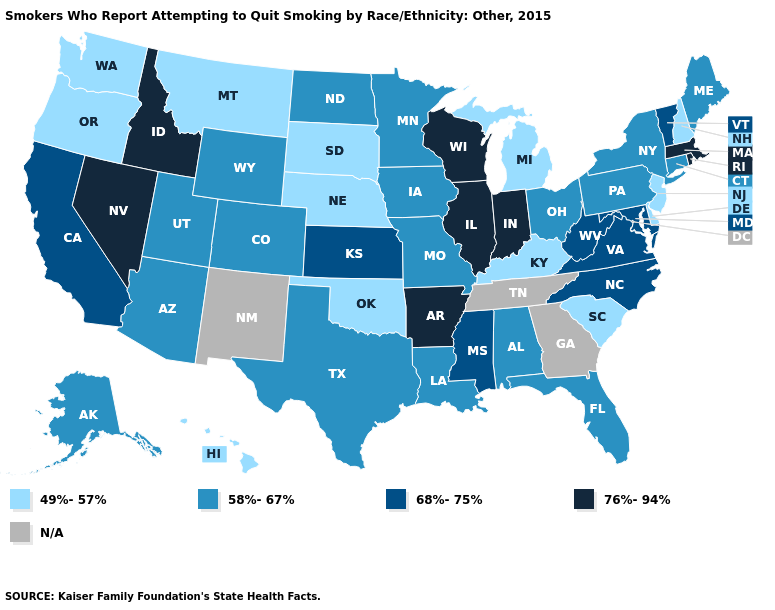What is the value of Arkansas?
Keep it brief. 76%-94%. Name the states that have a value in the range N/A?
Answer briefly. Georgia, New Mexico, Tennessee. Does New Jersey have the lowest value in the USA?
Answer briefly. Yes. What is the value of Nevada?
Concise answer only. 76%-94%. Name the states that have a value in the range 68%-75%?
Write a very short answer. California, Kansas, Maryland, Mississippi, North Carolina, Vermont, Virginia, West Virginia. What is the highest value in states that border New Mexico?
Give a very brief answer. 58%-67%. Which states hav the highest value in the West?
Give a very brief answer. Idaho, Nevada. What is the value of South Carolina?
Keep it brief. 49%-57%. Does West Virginia have the highest value in the USA?
Write a very short answer. No. Name the states that have a value in the range 76%-94%?
Be succinct. Arkansas, Idaho, Illinois, Indiana, Massachusetts, Nevada, Rhode Island, Wisconsin. What is the value of Maryland?
Quick response, please. 68%-75%. Among the states that border Ohio , which have the highest value?
Write a very short answer. Indiana. What is the lowest value in the MidWest?
Answer briefly. 49%-57%. Does West Virginia have the lowest value in the South?
Write a very short answer. No. 